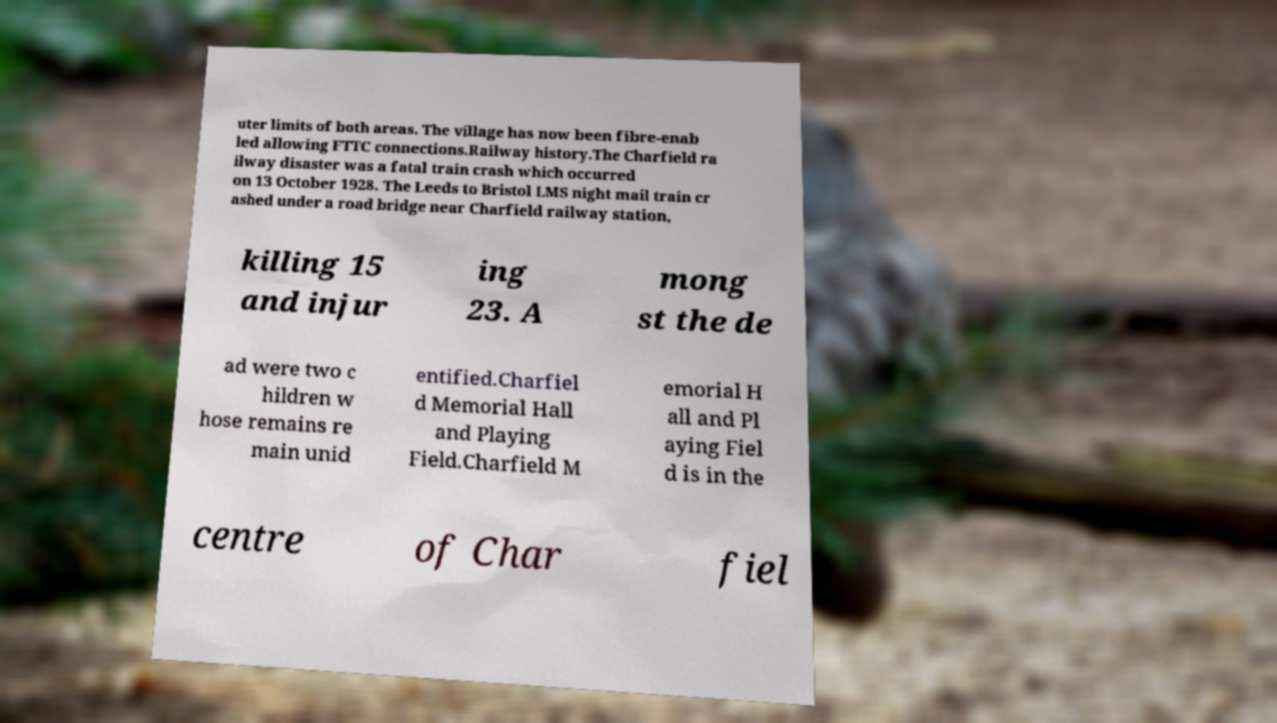Please identify and transcribe the text found in this image. uter limits of both areas. The village has now been fibre-enab led allowing FTTC connections.Railway history.The Charfield ra ilway disaster was a fatal train crash which occurred on 13 October 1928. The Leeds to Bristol LMS night mail train cr ashed under a road bridge near Charfield railway station, killing 15 and injur ing 23. A mong st the de ad were two c hildren w hose remains re main unid entified.Charfiel d Memorial Hall and Playing Field.Charfield M emorial H all and Pl aying Fiel d is in the centre of Char fiel 